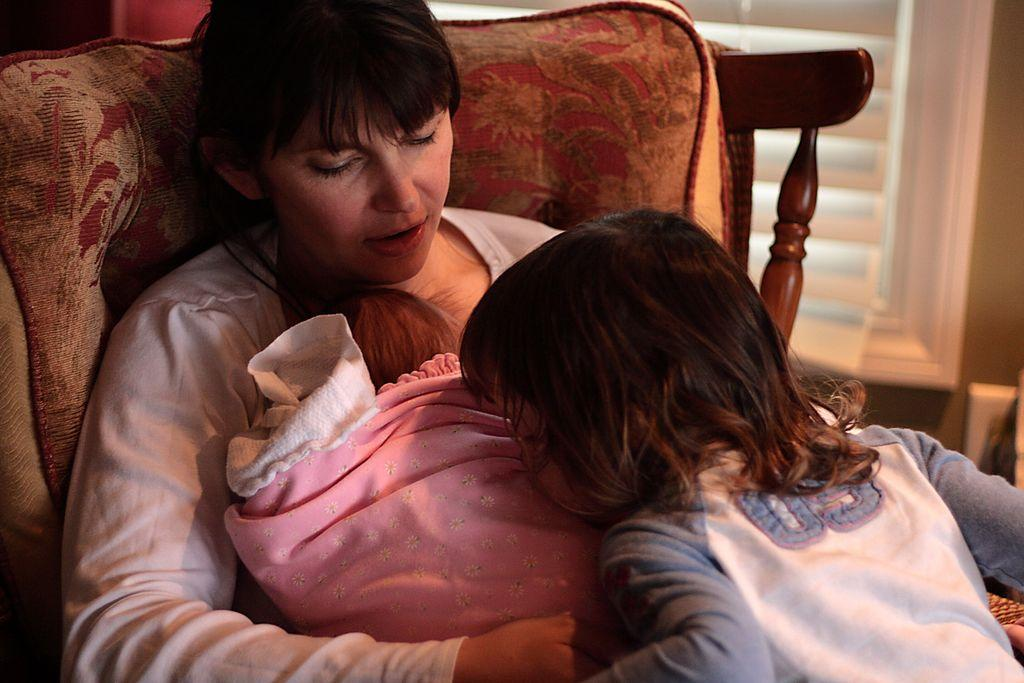Who is the main subject in the image? There is a woman in the image. What is the woman doing in the image? The woman is sitting and holding a baby in her lap. Can you describe the other person in the image? There is a child in the image, and the child is standing. What is the child doing in the image? The child is kissing. What type of duck can be seen in the image? There is no duck present in the image. Is the car parked nearby in the image? There is no car mentioned or visible in the image. 